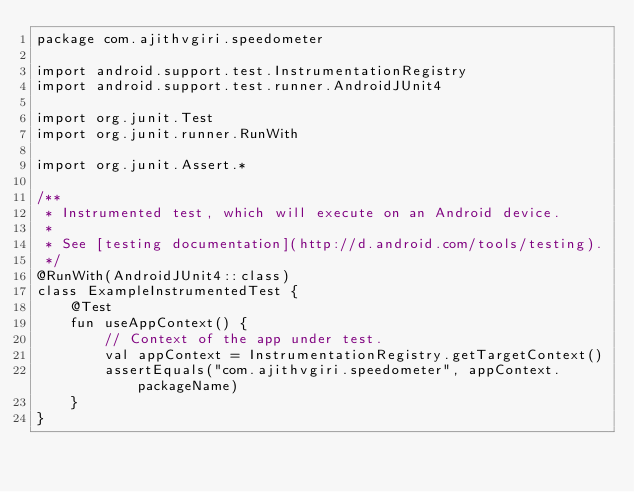Convert code to text. <code><loc_0><loc_0><loc_500><loc_500><_Kotlin_>package com.ajithvgiri.speedometer

import android.support.test.InstrumentationRegistry
import android.support.test.runner.AndroidJUnit4

import org.junit.Test
import org.junit.runner.RunWith

import org.junit.Assert.*

/**
 * Instrumented test, which will execute on an Android device.
 *
 * See [testing documentation](http://d.android.com/tools/testing).
 */
@RunWith(AndroidJUnit4::class)
class ExampleInstrumentedTest {
    @Test
    fun useAppContext() {
        // Context of the app under test.
        val appContext = InstrumentationRegistry.getTargetContext()
        assertEquals("com.ajithvgiri.speedometer", appContext.packageName)
    }
}
</code> 